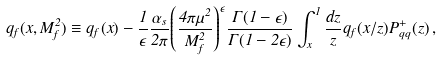Convert formula to latex. <formula><loc_0><loc_0><loc_500><loc_500>q _ { f } ( x , M _ { f } ^ { 2 } ) \equiv q _ { f } ( x ) - { \frac { 1 } { \epsilon } } { \frac { \alpha _ { s } } { 2 \pi } } { \left ( { \frac { 4 \pi \mu ^ { 2 } } { M _ { f } ^ { 2 } } } \right ) } ^ { \epsilon } { \frac { \Gamma ( 1 - \epsilon ) } { \Gamma ( 1 - 2 \epsilon ) } } \int _ { x } ^ { 1 } { \frac { d z } { z } } q _ { f } ( x / z ) P _ { q q } ^ { + } ( z ) \, ,</formula> 